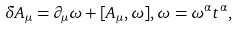Convert formula to latex. <formula><loc_0><loc_0><loc_500><loc_500>\delta A _ { \mu } = \partial _ { \mu } \omega + [ A _ { \mu } , \omega ] , \omega = \omega ^ { \alpha } t ^ { \alpha } ,</formula> 